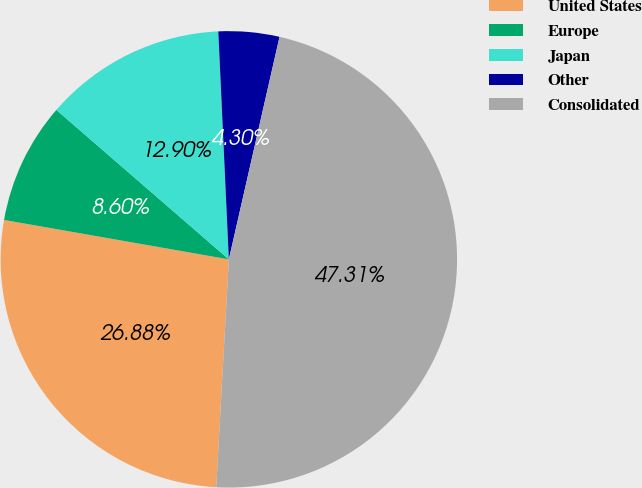Convert chart. <chart><loc_0><loc_0><loc_500><loc_500><pie_chart><fcel>United States<fcel>Europe<fcel>Japan<fcel>Other<fcel>Consolidated<nl><fcel>26.88%<fcel>8.6%<fcel>12.9%<fcel>4.3%<fcel>47.31%<nl></chart> 